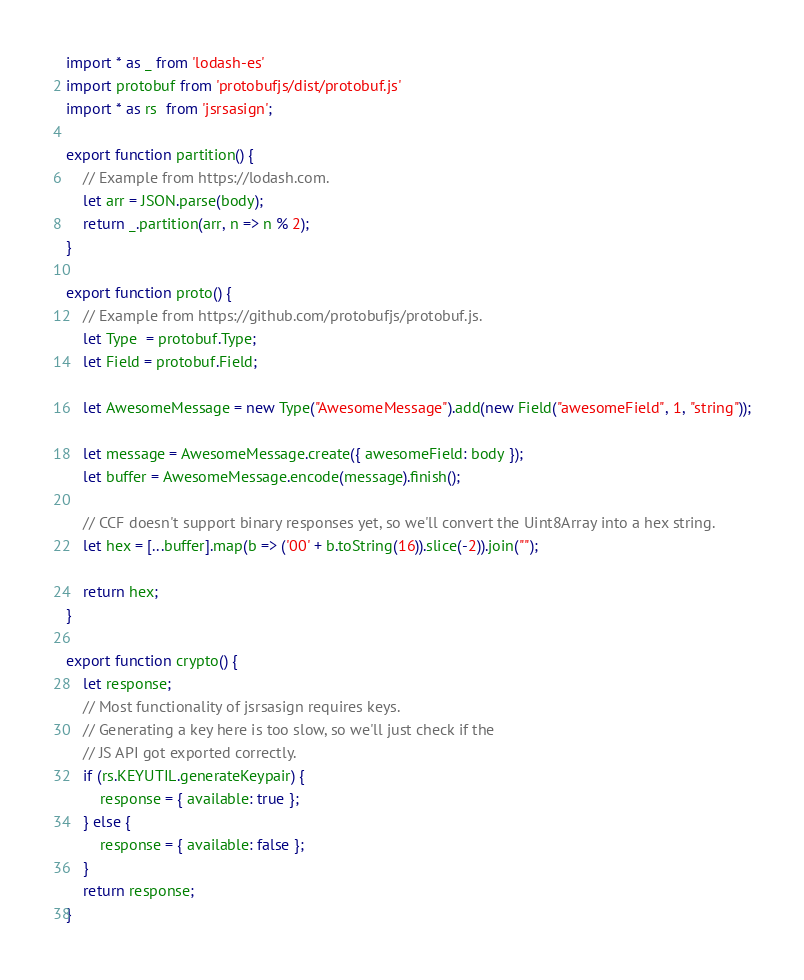Convert code to text. <code><loc_0><loc_0><loc_500><loc_500><_JavaScript_>import * as _ from 'lodash-es'
import protobuf from 'protobufjs/dist/protobuf.js'
import * as rs  from 'jsrsasign';

export function partition() {
    // Example from https://lodash.com.
    let arr = JSON.parse(body);
    return _.partition(arr, n => n % 2);
}

export function proto() {
    // Example from https://github.com/protobufjs/protobuf.js.
    let Type  = protobuf.Type;
    let Field = protobuf.Field;
 
    let AwesomeMessage = new Type("AwesomeMessage").add(new Field("awesomeField", 1, "string"));
    
    let message = AwesomeMessage.create({ awesomeField: body });
    let buffer = AwesomeMessage.encode(message).finish();

    // CCF doesn't support binary responses yet, so we'll convert the Uint8Array into a hex string.
    let hex = [...buffer].map(b => ('00' + b.toString(16)).slice(-2)).join("");

    return hex;
}

export function crypto() {
    let response;
    // Most functionality of jsrsasign requires keys.
    // Generating a key here is too slow, so we'll just check if the
    // JS API got exported correctly.
    if (rs.KEYUTIL.generateKeypair) {
        response = { available: true };
    } else {
        response = { available: false };
    }
    return response;
}
</code> 